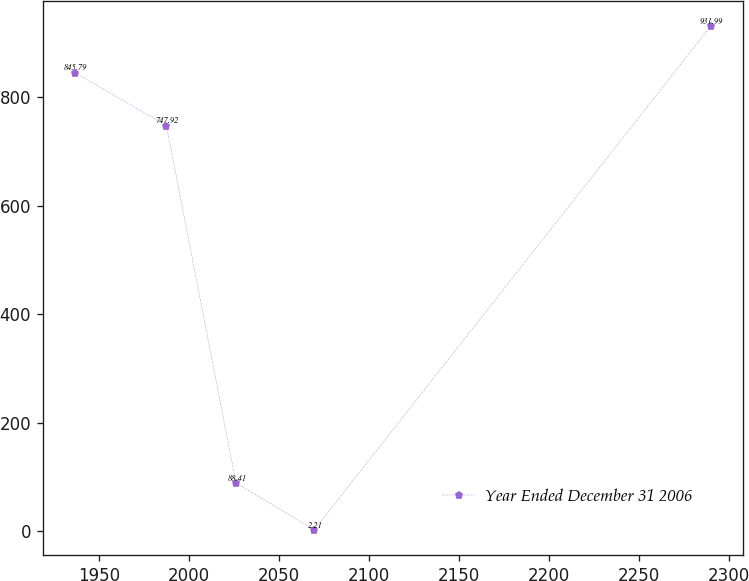<chart> <loc_0><loc_0><loc_500><loc_500><line_chart><ecel><fcel>Year Ended December 31 2006<nl><fcel>1936.6<fcel>845.79<nl><fcel>1987.56<fcel>747.92<nl><fcel>2026.22<fcel>88.41<nl><fcel>2069.67<fcel>2.21<nl><fcel>2289.97<fcel>931.99<nl></chart> 